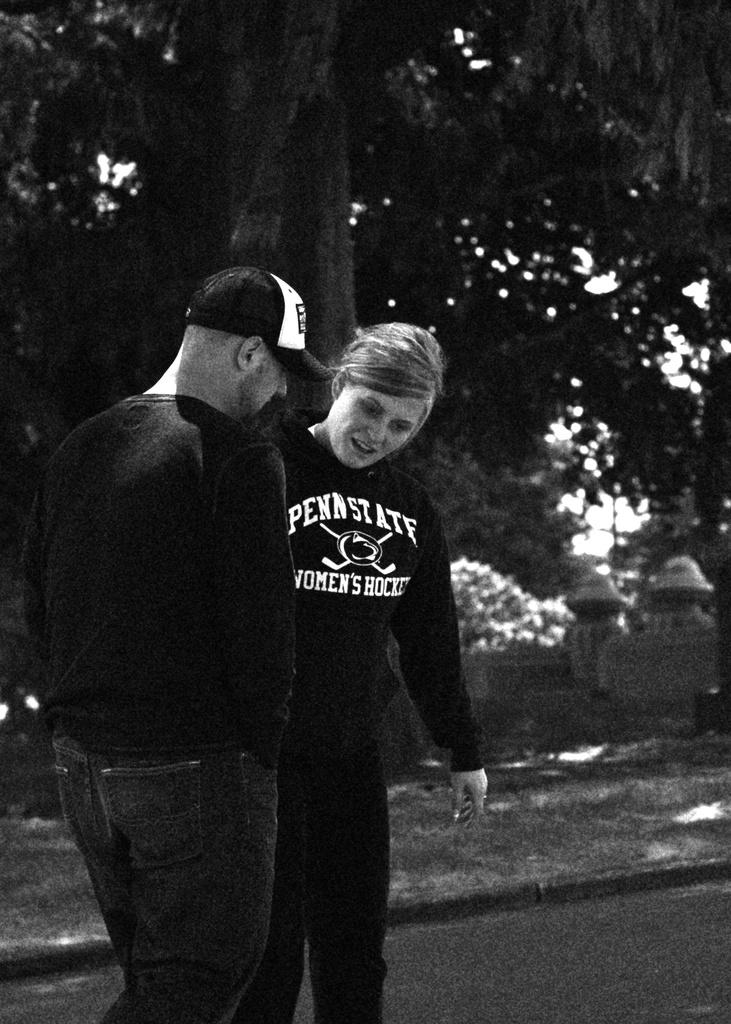How many people are in the image? There are two people in the image. What are the two people doing in the image? The two people are standing on the road. What can be seen in the background of the image? There is a tree visible in the image. What type of fowl is sitting on the can in the image? There is no can or fowl present in the image. What month is it in the image? The image does not provide any information about the month. 